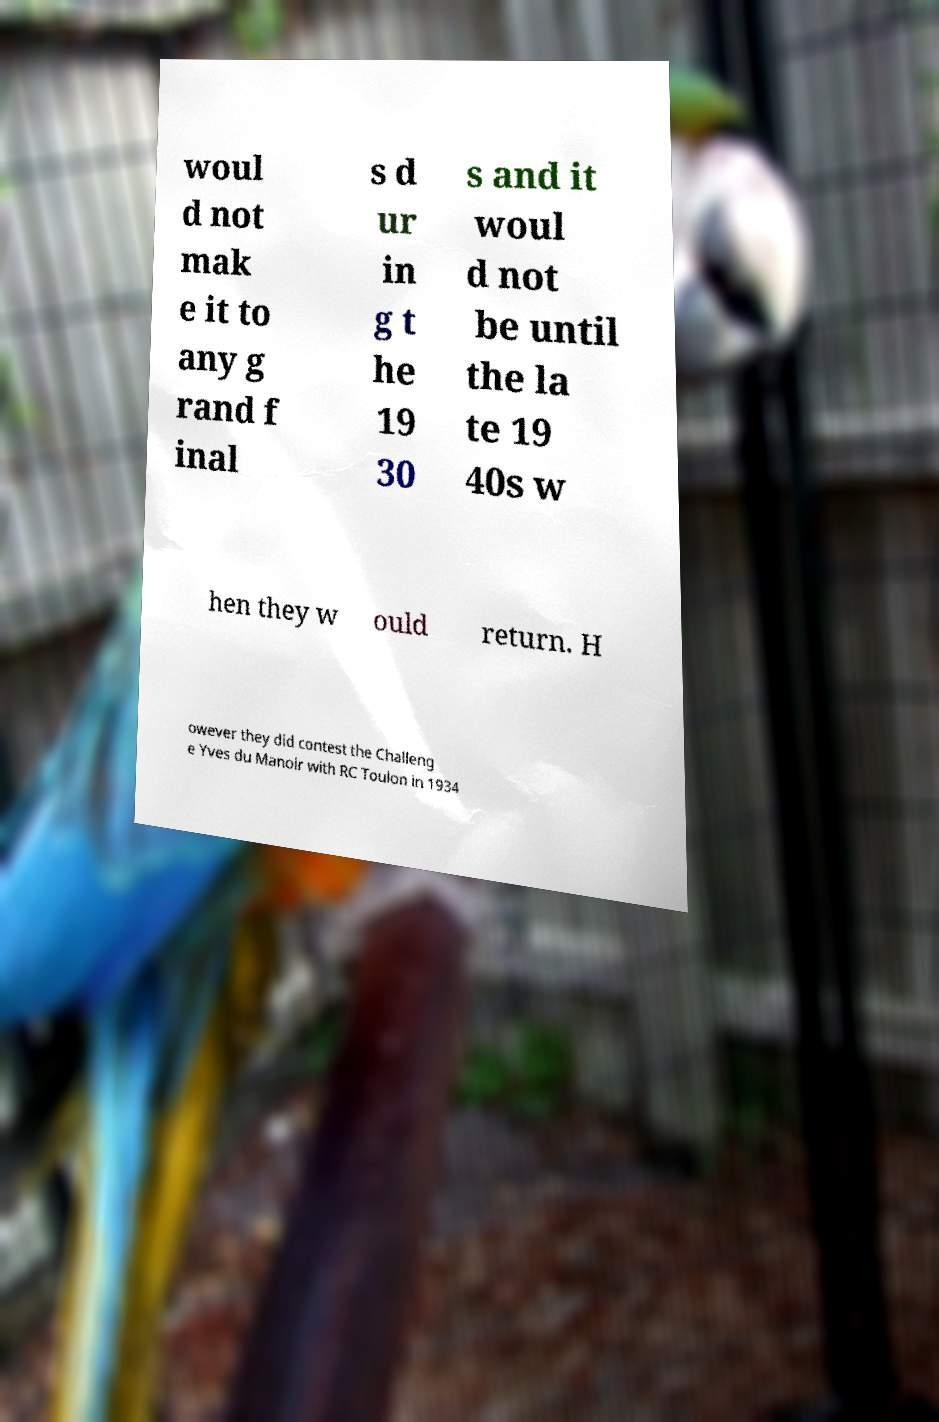There's text embedded in this image that I need extracted. Can you transcribe it verbatim? woul d not mak e it to any g rand f inal s d ur in g t he 19 30 s and it woul d not be until the la te 19 40s w hen they w ould return. H owever they did contest the Challeng e Yves du Manoir with RC Toulon in 1934 